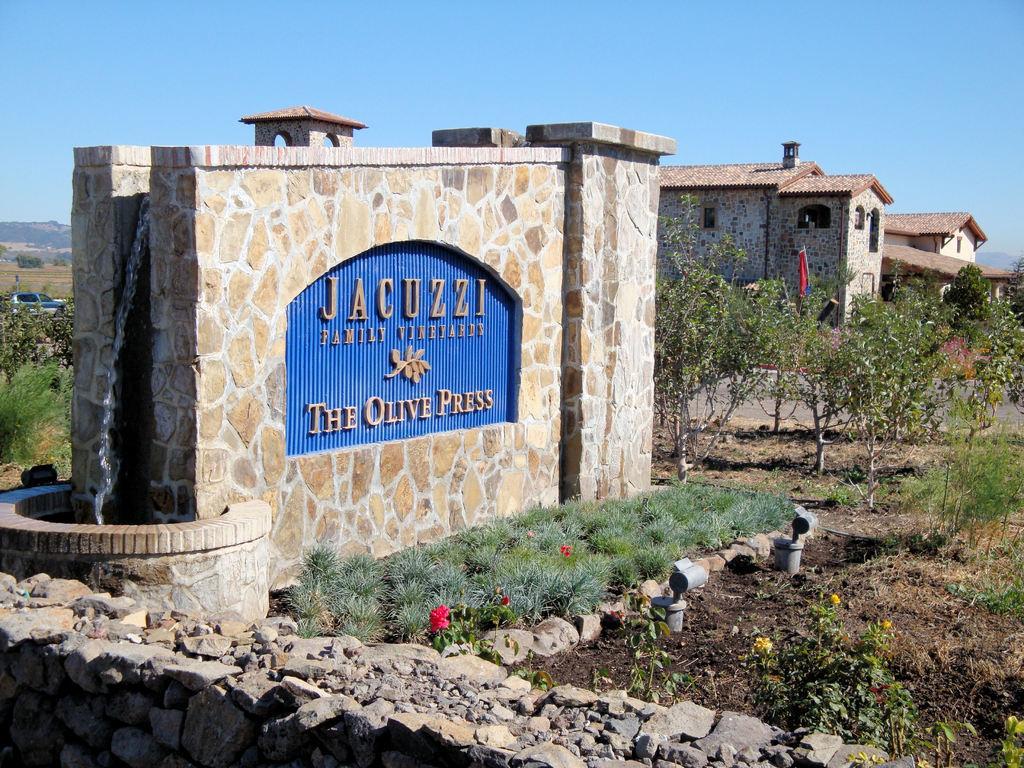Could you give a brief overview of what you see in this image? In this image I can see a house and in front of house there is a road and plant visible, on the right side , there is the wall , on the wall there is a text, in front of wall there is a grass, some plants, flowers, at the bottom there is the stone wall.,at the top there is the sky visible , on the left side I can see vehicle and the sky visible. 